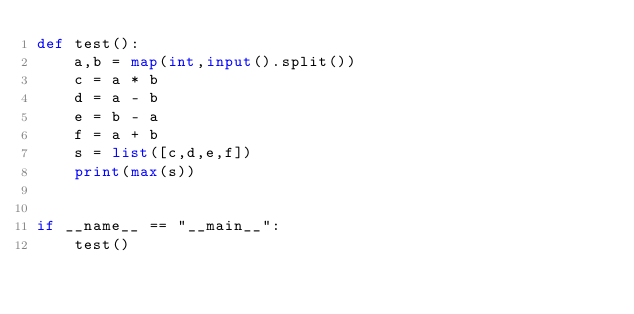<code> <loc_0><loc_0><loc_500><loc_500><_Python_>def test():
    a,b = map(int,input().split())
    c = a * b
    d = a - b
    e = b - a
    f = a + b
    s = list([c,d,e,f])
    print(max(s))


if __name__ == "__main__":
    test()
</code> 